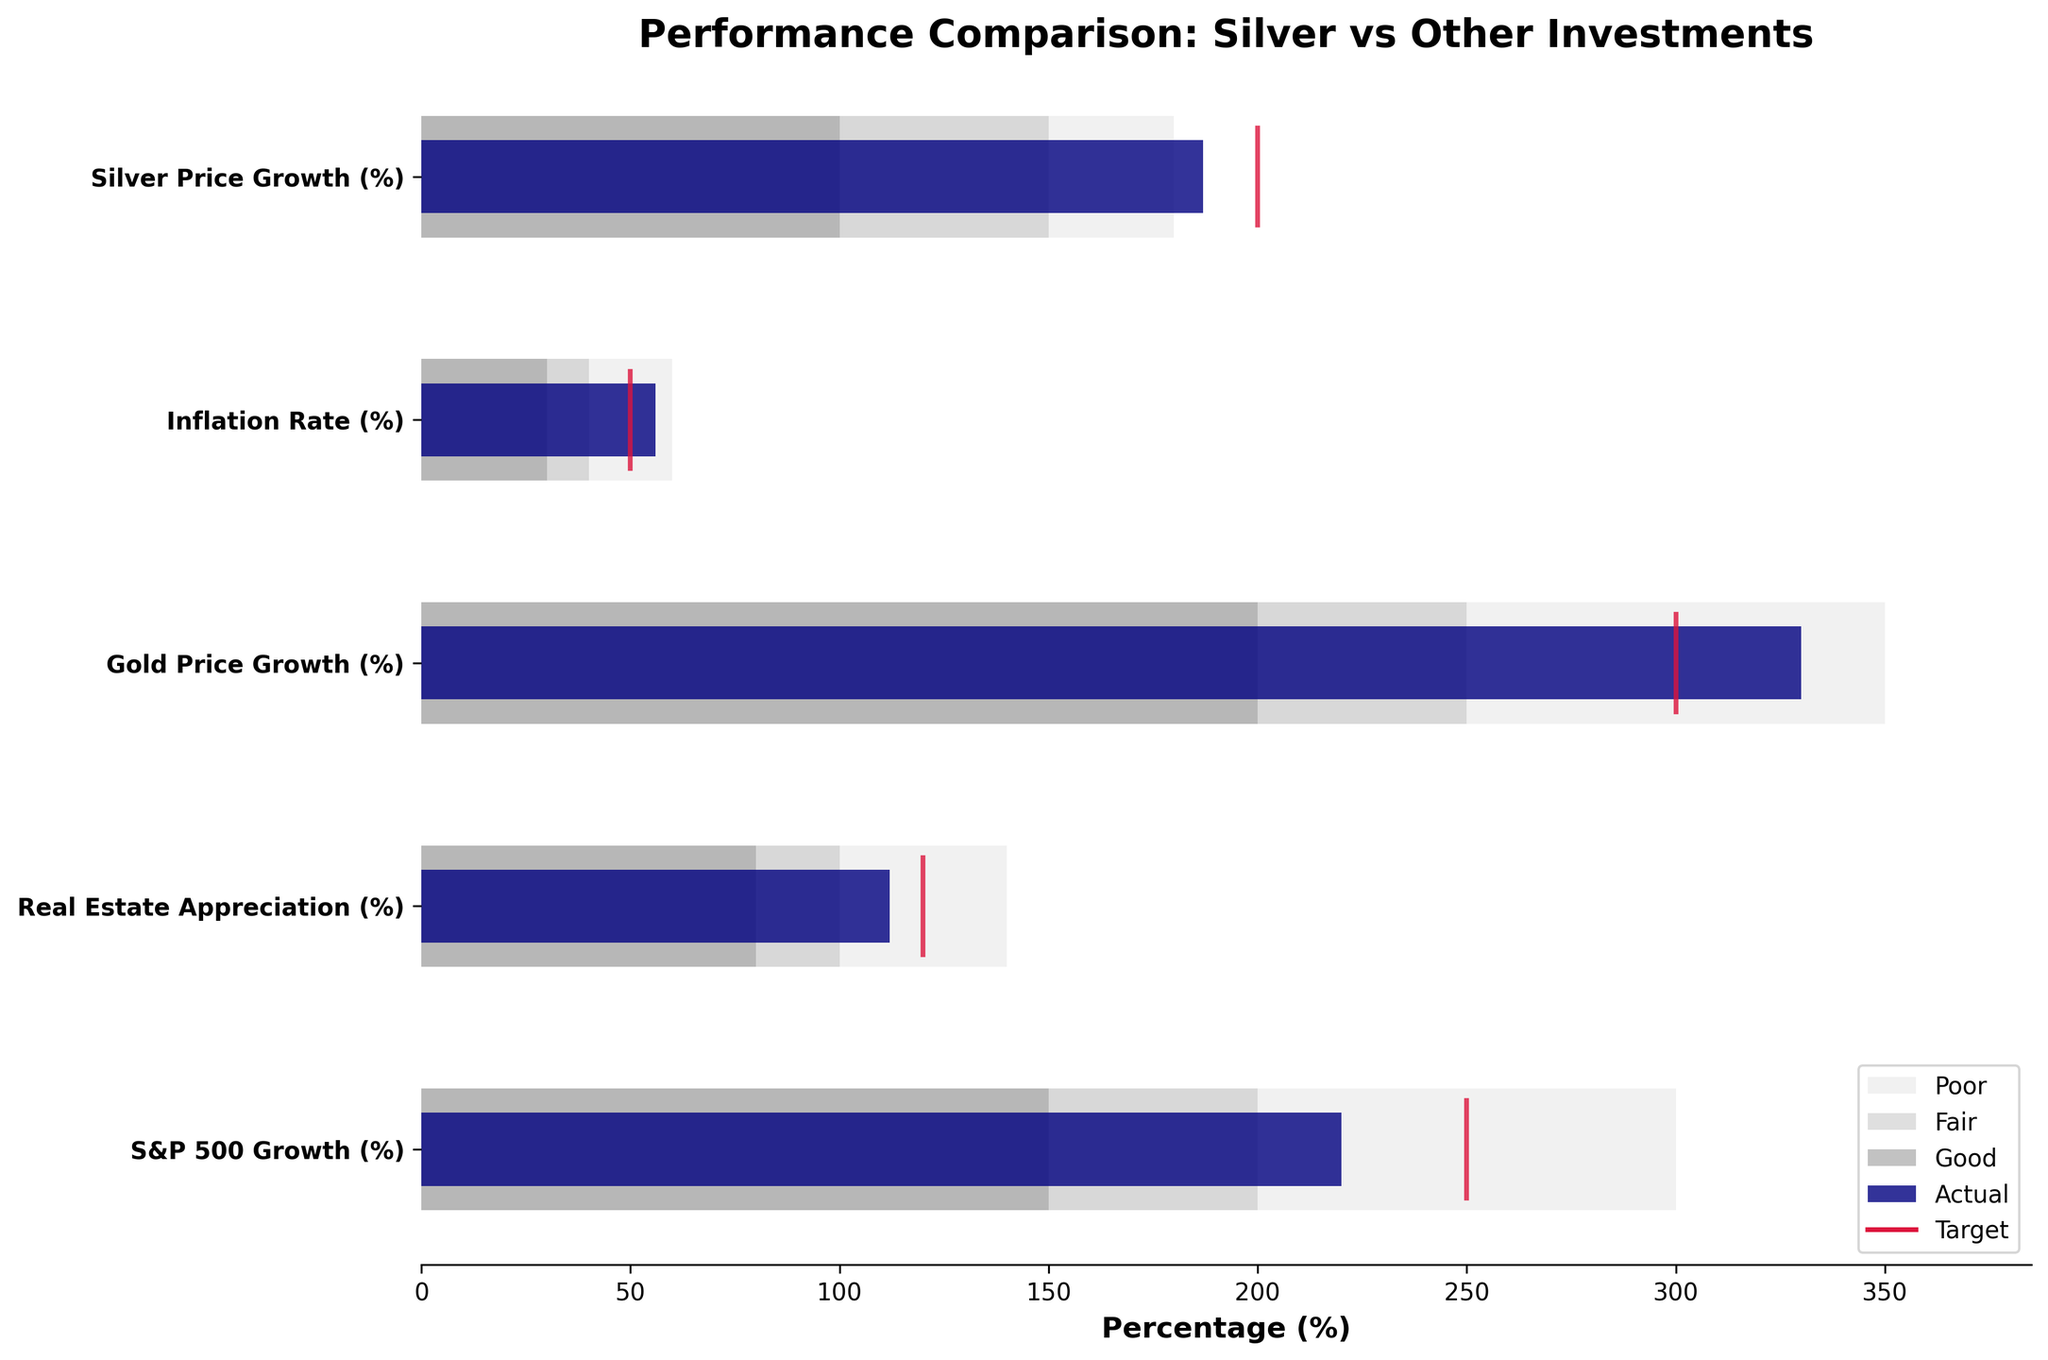What's the title of the figure? The answer can be found at the top of the figure, where the title is usually placed. The title of the figure is "Performance Comparison: Silver vs Other Investments".
Answer: Performance Comparison: Silver vs Other Investments What are the five categories compared in the chart? The categories are listed on the y-axis of the figure. They are "Silver Price Growth (%)", "Inflation Rate (%)", "Gold Price Growth (%)", "Real Estate Appreciation (%)", and "S&P 500 Growth (%)".
Answer: Silver Price Growth (%), Inflation Rate (%), Gold Price Growth (%), Real Estate Appreciation (%), S&P 500 Growth (%) What is the actual growth percentage of Silver Price? The actual growth percentage is shown as a dark navy bar corresponding to "Silver Price Growth (%)". This value is 187%.
Answer: 187% Which category exceeded its target value the most? To find this, compare the difference between the actual and target values for each category. "Gold Price Growth (%)" has an actual value of 330% and a target of 300%, exceeding its target by 30%, which is the highest positive difference.
Answer: Gold Price Growth (%) How does the actual growth of Silver Price compare to its target? Compare the dark navy bar (actual) to the small crimson line (target) for "Silver Price Growth (%)". The actual value (187%) is below the target value (200%).
Answer: Below target Which category has the highest actual value? Look for the longest dark navy bar in the figure. This corresponds to "Gold Price Growth (%)", with an actual value of 330%.
Answer: Gold Price Growth (%) What range does the inflation rate fall into? The inflation rate's actual value is 56%, which can be compared to the background ranges for that category. It falls into the light grey and silver segments, corresponding to "Poor" and "Fair".
Answer: Poor and Fair Which investment had the poorest actual performance relative to its target? Calculate the difference between actual and target values. For "Real Estate Appreciation (%)", the actual is 112% and the target is 120%, resulting in a gap of -8%, the largest negative difference.
Answer: Real Estate Appreciation (%) What can you say about the target ranges of S&P 500 Growth and Gold Price Growth? Compare their crimson lines (targets) and light grey, silver, and dark grey bars (ranges) for each category. Both categories have similar extensive ranges and their target values are very comparable but S&P 500 ranges higher overall.
Answer: Comparable ranges and targets 